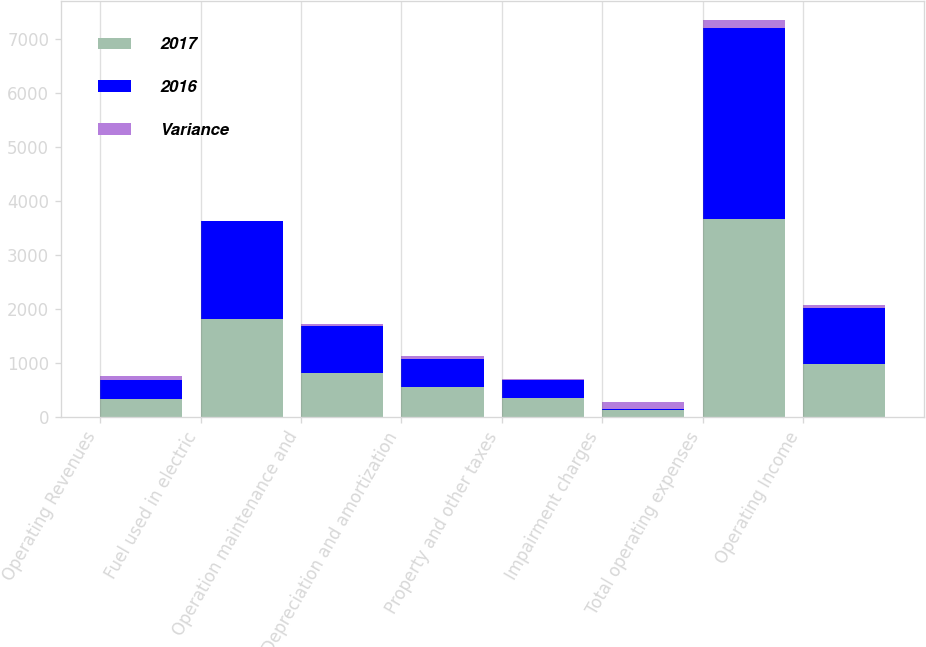Convert chart to OTSL. <chart><loc_0><loc_0><loc_500><loc_500><stacked_bar_chart><ecel><fcel>Operating Revenues<fcel>Fuel used in electric<fcel>Operation maintenance and<fcel>Depreciation and amortization<fcel>Property and other taxes<fcel>Impairment charges<fcel>Total operating expenses<fcel>Operating Income<nl><fcel>2017<fcel>340<fcel>1808<fcel>818<fcel>560<fcel>347<fcel>138<fcel>3671<fcel>976<nl><fcel>2016<fcel>340<fcel>1814<fcel>865<fcel>509<fcel>333<fcel>6<fcel>3527<fcel>1041<nl><fcel>Variance<fcel>78<fcel>6<fcel>47<fcel>51<fcel>14<fcel>132<fcel>144<fcel>65<nl></chart> 